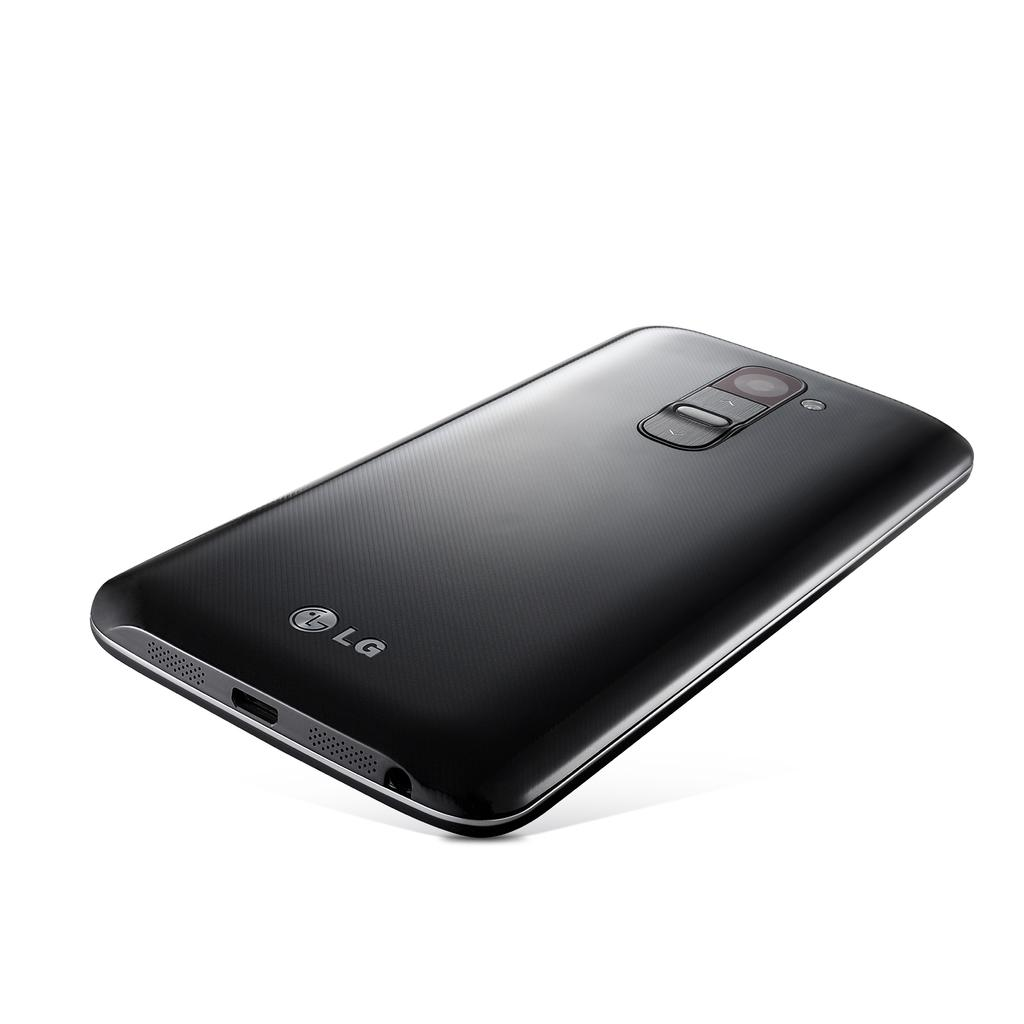<image>
Describe the image concisely. An LG phone that is black in with a plain white backdrop 